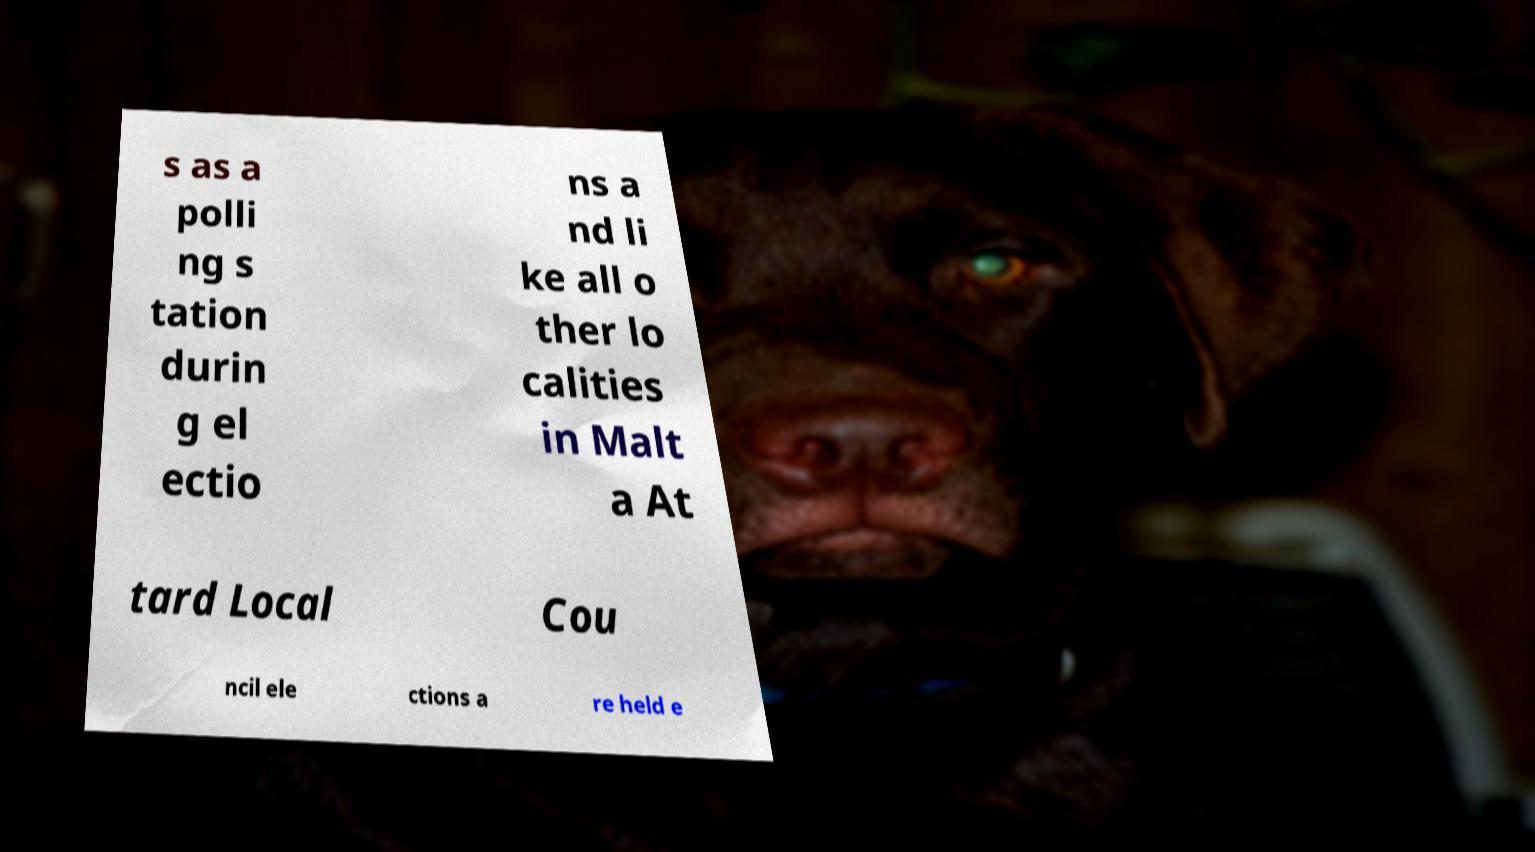Can you read and provide the text displayed in the image?This photo seems to have some interesting text. Can you extract and type it out for me? s as a polli ng s tation durin g el ectio ns a nd li ke all o ther lo calities in Malt a At tard Local Cou ncil ele ctions a re held e 